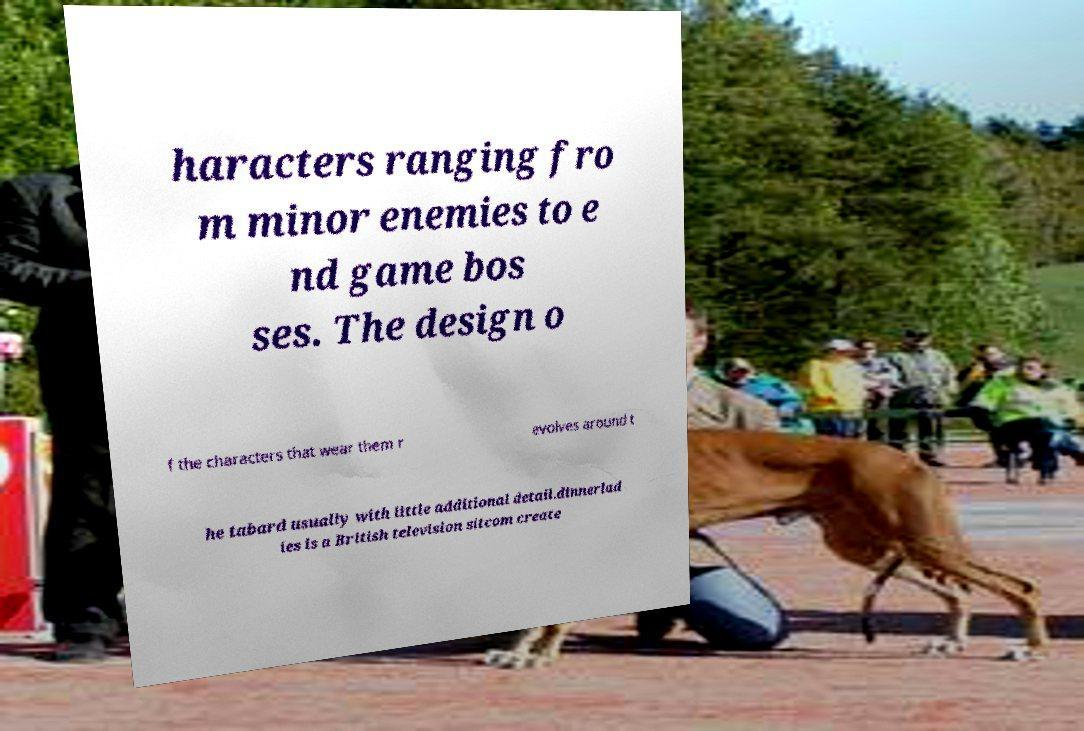For documentation purposes, I need the text within this image transcribed. Could you provide that? haracters ranging fro m minor enemies to e nd game bos ses. The design o f the characters that wear them r evolves around t he tabard usually with little additional detail.dinnerlad ies is a British television sitcom create 